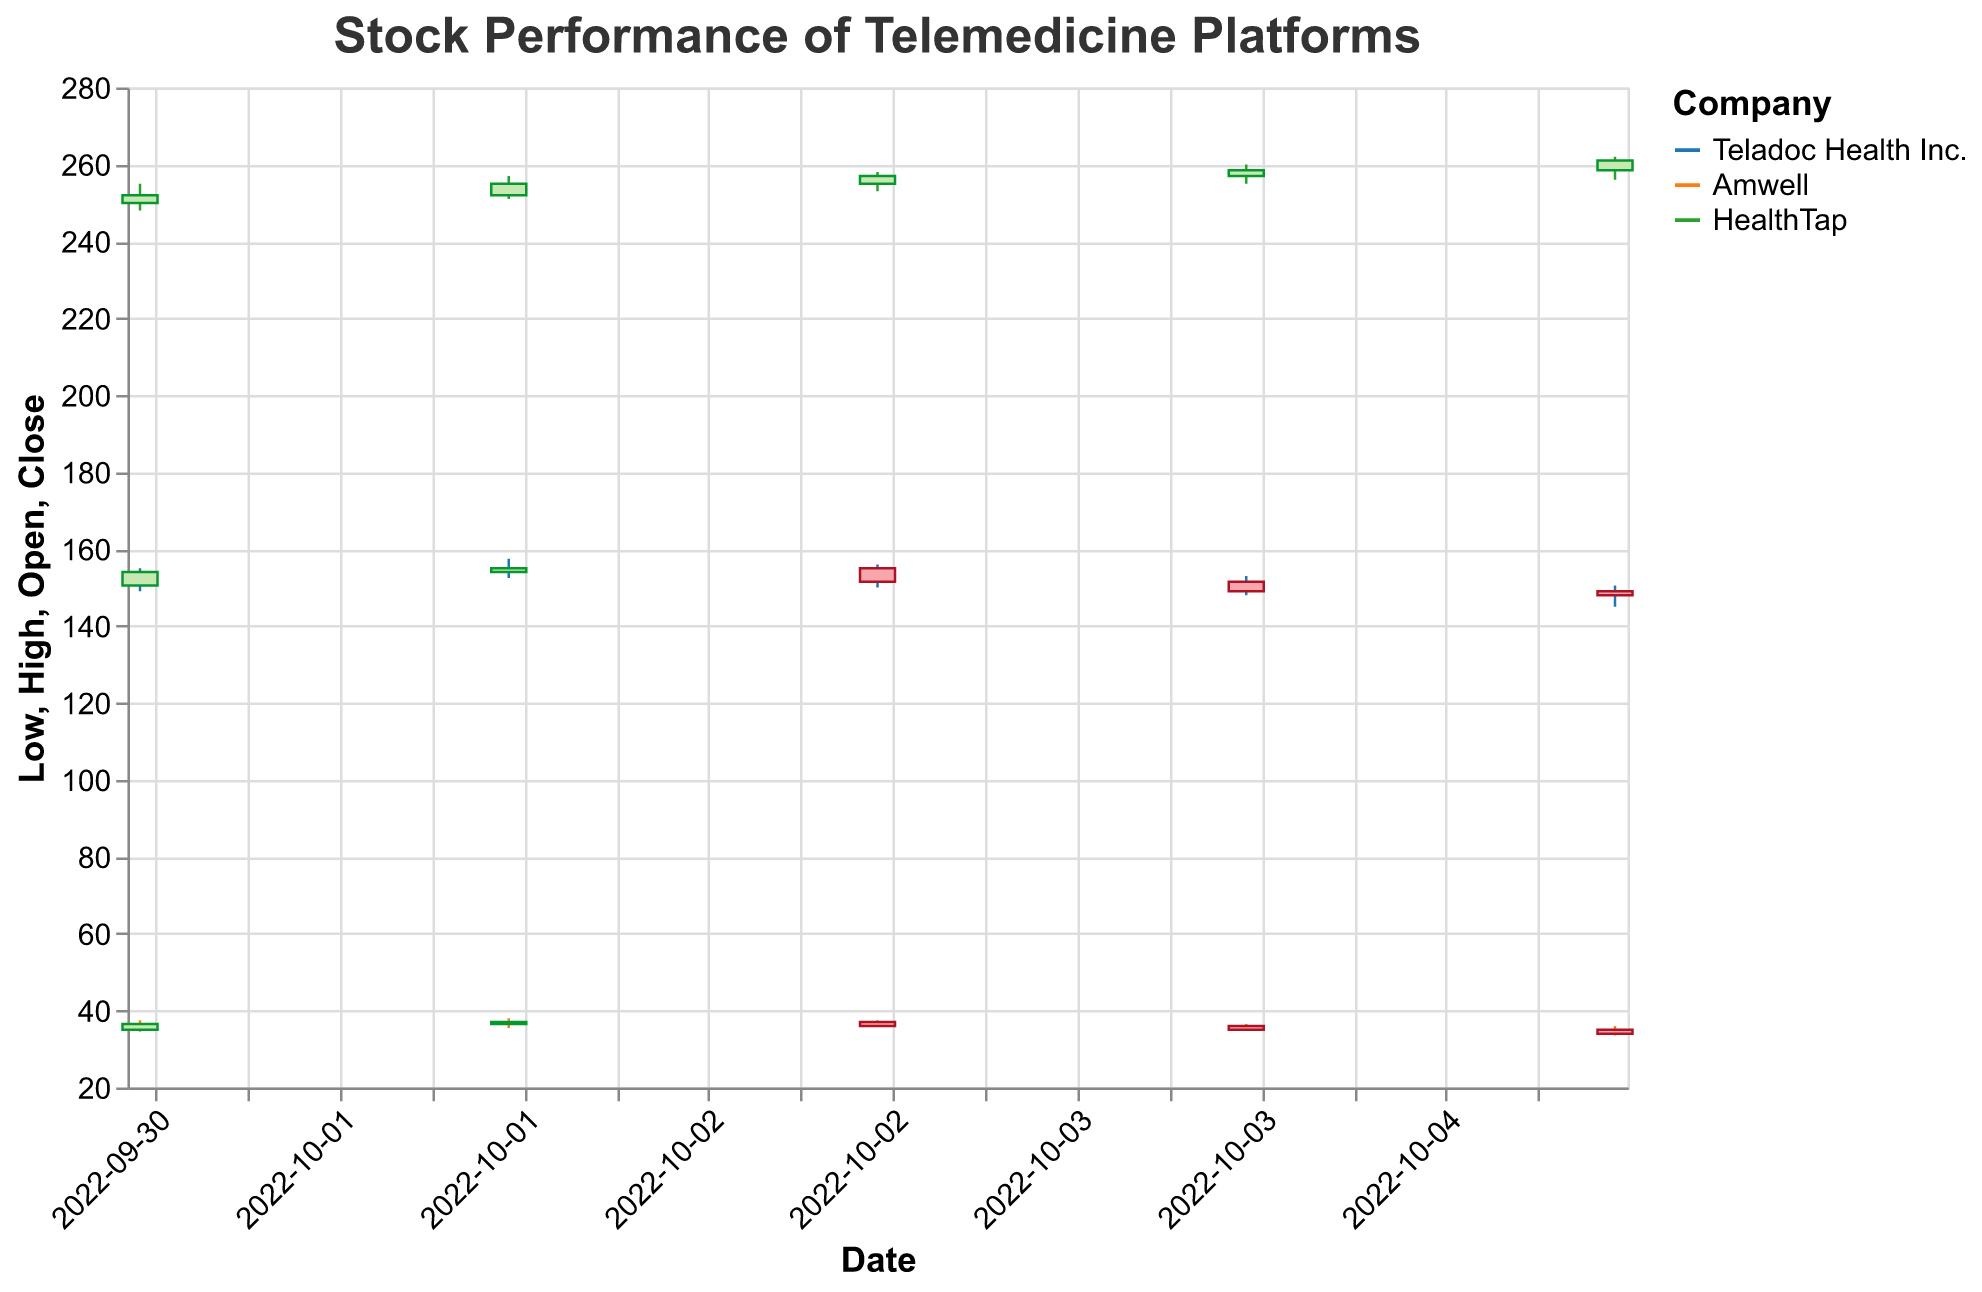What is the title of the figure? The title is displayed at the top of the figure and provides an overview of what the plot represents. Here, it reads "Stock Performance of Telemedicine Platforms".
Answer: Stock Performance of Telemedicine Platforms Which company had the highest closing price on October 5, 2022? From the plot, the closing prices for October 5, 2022, can be observed for each company. HealthTap shows a closing price of 261.0, which is the highest among the companies listed.
Answer: HealthTap How many companies are being compared in the figure? By looking at the legend of the plot, which contains the company names, we can see three companies: Teladoc Health Inc., Amwell, and HealthTap.
Answer: 3 What was the closing price of Amwell on October 2, 2022? The candlestick for Amwell on October 2, 2022, indicates the closing price. In this case, the close price for Amwell is 37.0.
Answer: 37.0 Which company experienced the greatest increase in closing price from October 1 to October 5, 2022? To determine this, we compare the closing prices on October 1 and October 5 for each company:
- Teladoc: 154.0 to 148.0 (decrease)
- Amwell: 36.5 to 34.0 (decrease)
- HealthTap: 252.0 to 261.0 (increase")
HealthTap had an increase from 252.0 to 261.0.
Answer: HealthTap What is the overall trend for Teladoc Health Inc.'s closing prices from October 1 to October 5, 2022? Observing the candlesticks for Teladoc Health Inc. from October 1 to October 5, we see a decline in closing price from 154.0 down to 148.0. The trend is downward.
Answer: Downward What's the difference in volume traded between HealthTap and Amwell on October 1, 2022? The volume traded can be found on the vertical axis marked as volume for each candlestick. On October 1, HealthTap had 1,500,000 and Amwell had 1,100,000. The difference is 1,500,000 - 1,100,000.
Answer: 400,000 Which company had the smallest range between high and low prices on October 4, 2022? To find the smallest range, subtract the low from the high price for each company on October 4, 2022:
- Teladoc: 153.0 - 148.0 = 5.0
- Amwell: 36.5 - 35.0 = 1.5
- HealthTap: 260.0 - 255.0 = 5.0
Amwell has the smallest range of 1.5.
Answer: Amwell Compare the highest prices reached by each company on October 3, 2022. Which company reached the highest price? The highest prices for each company on October 3, 2022, are:
- Teladoc: 156.0
- Amwell: 37.5
- HealthTap: 258.0
HealthTap reached the highest price of 258.0.
Answer: HealthTap 